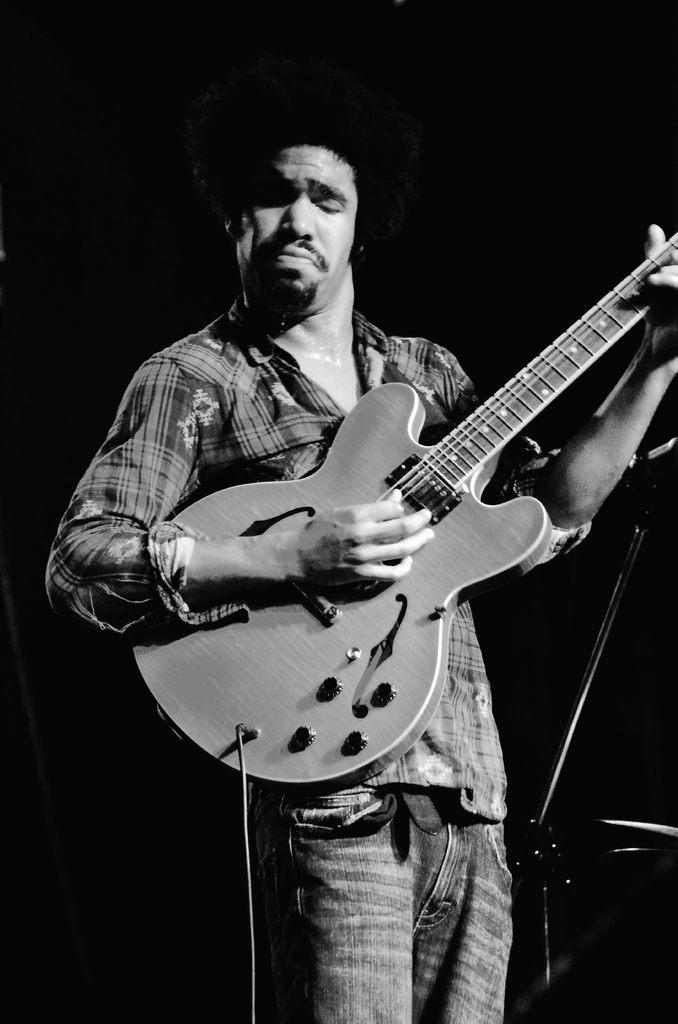What is the main subject of the image? The main subject of the image is a man. What is the man holding in the image? The man is holding a guitar in the image. What is the man doing with the guitar? The man is playing the guitar in the image. What type of disease is the man suffering from in the image? There is no indication of any disease in the image; the man is simply playing the guitar. 